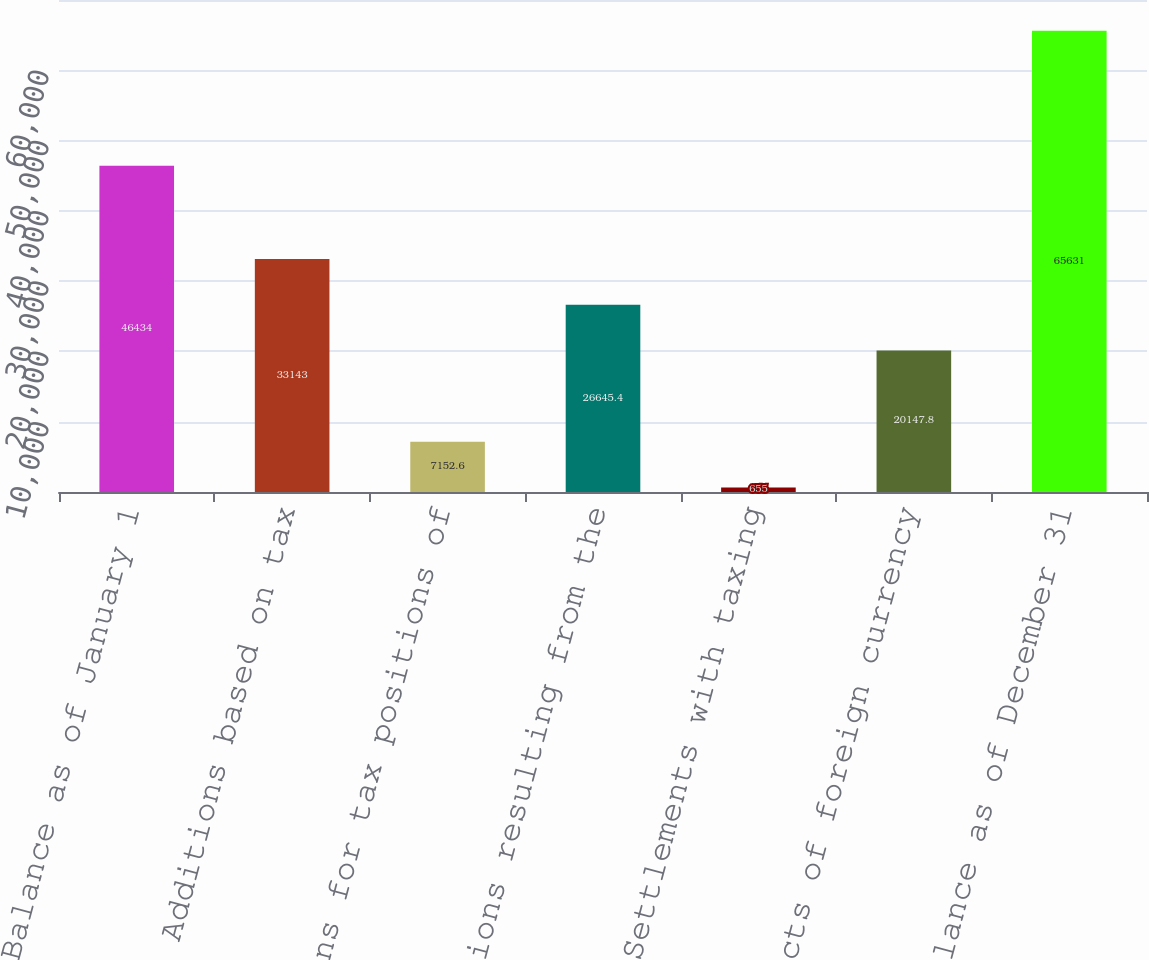Convert chart to OTSL. <chart><loc_0><loc_0><loc_500><loc_500><bar_chart><fcel>Balance as of January 1<fcel>Additions based on tax<fcel>Additions for tax positions of<fcel>Reductions resulting from the<fcel>Settlements with taxing<fcel>Effects of foreign currency<fcel>Balance as of December 31<nl><fcel>46434<fcel>33143<fcel>7152.6<fcel>26645.4<fcel>655<fcel>20147.8<fcel>65631<nl></chart> 